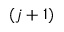<formula> <loc_0><loc_0><loc_500><loc_500>( j + 1 )</formula> 